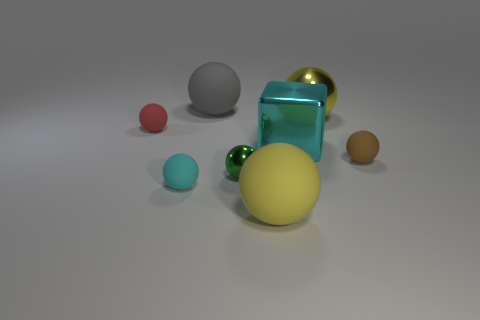Subtract all big yellow metallic balls. How many balls are left? 6 Subtract all brown cylinders. How many yellow spheres are left? 2 Add 1 cyan metallic spheres. How many objects exist? 9 Subtract 2 balls. How many balls are left? 5 Subtract all brown spheres. How many spheres are left? 6 Subtract all blocks. How many objects are left? 7 Subtract all red spheres. Subtract all cyan cylinders. How many spheres are left? 6 Subtract 0 brown blocks. How many objects are left? 8 Subtract all tiny red spheres. Subtract all yellow matte objects. How many objects are left? 6 Add 7 big gray objects. How many big gray objects are left? 8 